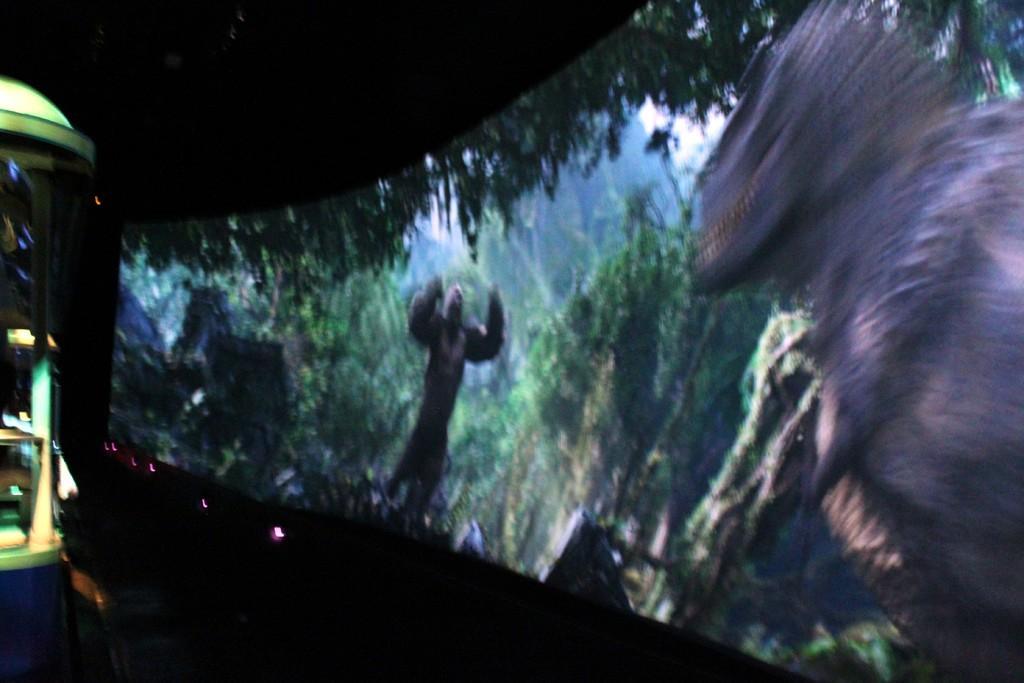Please provide a concise description of this image. In this picture there is a screen and there are animals, trees and there is sky on the screen. On the left side of the image there is an object. At the bottom there is a plant. 